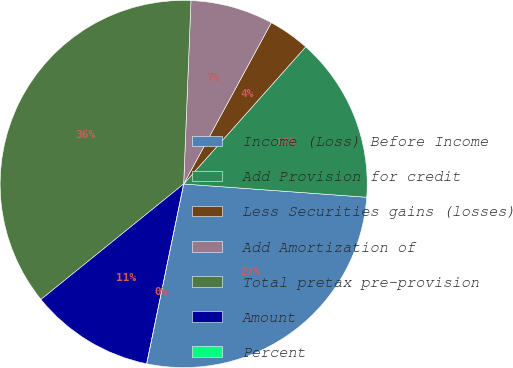<chart> <loc_0><loc_0><loc_500><loc_500><pie_chart><fcel>Income (Loss) Before Income<fcel>Add Provision for credit<fcel>Less Securities gains (losses)<fcel>Add Amortization of<fcel>Total pretax pre-provision<fcel>Amount<fcel>Percent<nl><fcel>27.08%<fcel>14.58%<fcel>3.65%<fcel>7.29%<fcel>36.46%<fcel>10.94%<fcel>0.0%<nl></chart> 